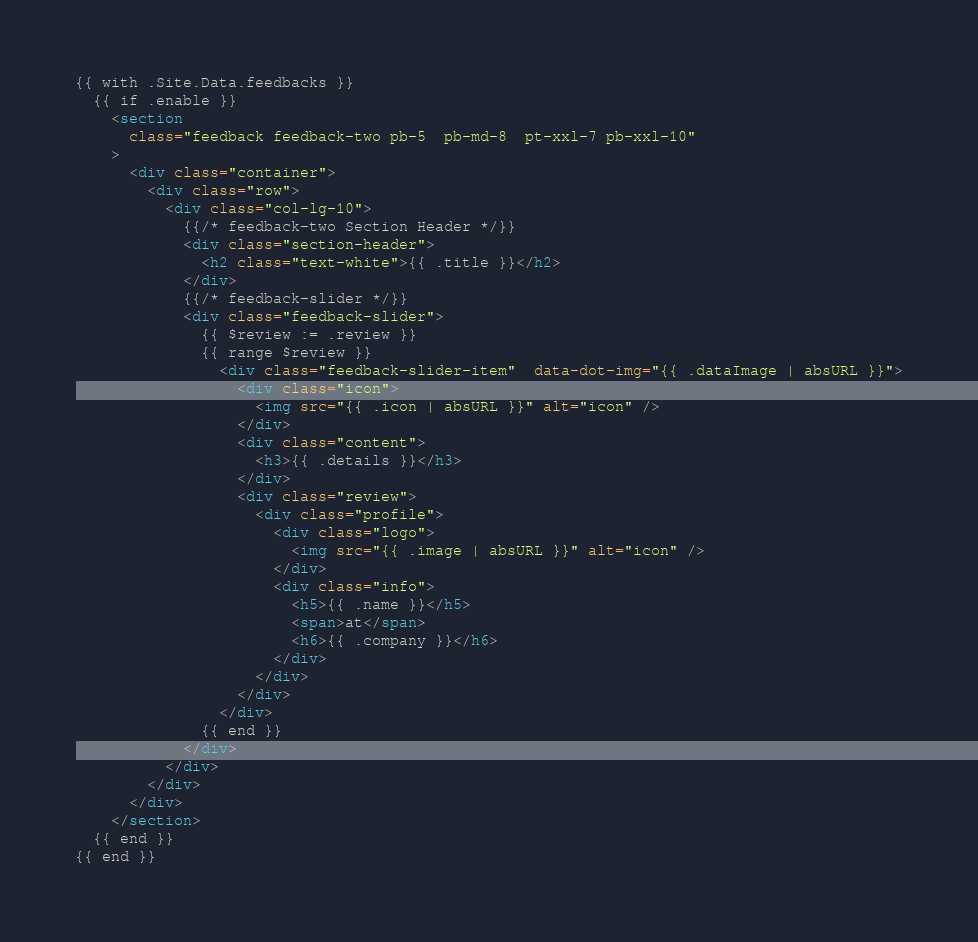<code> <loc_0><loc_0><loc_500><loc_500><_HTML_>{{ with .Site.Data.feedbacks }}
  {{ if .enable }}
    <section
      class="feedback feedback-two pb-5  pb-md-8  pt-xxl-7 pb-xxl-10"
    >
      <div class="container">
        <div class="row">
          <div class="col-lg-10">
            {{/* feedback-two Section Header */}}
            <div class="section-header">
              <h2 class="text-white">{{ .title }}</h2>
            </div>
            {{/* feedback-slider */}}
            <div class="feedback-slider">
              {{ $review := .review }}
              {{ range $review }}
                <div class="feedback-slider-item"  data-dot-img="{{ .dataImage | absURL }}">
                  <div class="icon">
                    <img src="{{ .icon | absURL }}" alt="icon" />
                  </div>
                  <div class="content">
                    <h3>{{ .details }}</h3>
                  </div>
                  <div class="review">
                    <div class="profile">
                      <div class="logo">
                        <img src="{{ .image | absURL }}" alt="icon" />
                      </div>
                      <div class="info">
                        <h5>{{ .name }}</h5>
                        <span>at</span>
                        <h6>{{ .company }}</h6>
                      </div>
                    </div>
                  </div>
                </div>
              {{ end }}
            </div>
          </div>
        </div>
      </div>
    </section>
  {{ end }}
{{ end }}</code> 